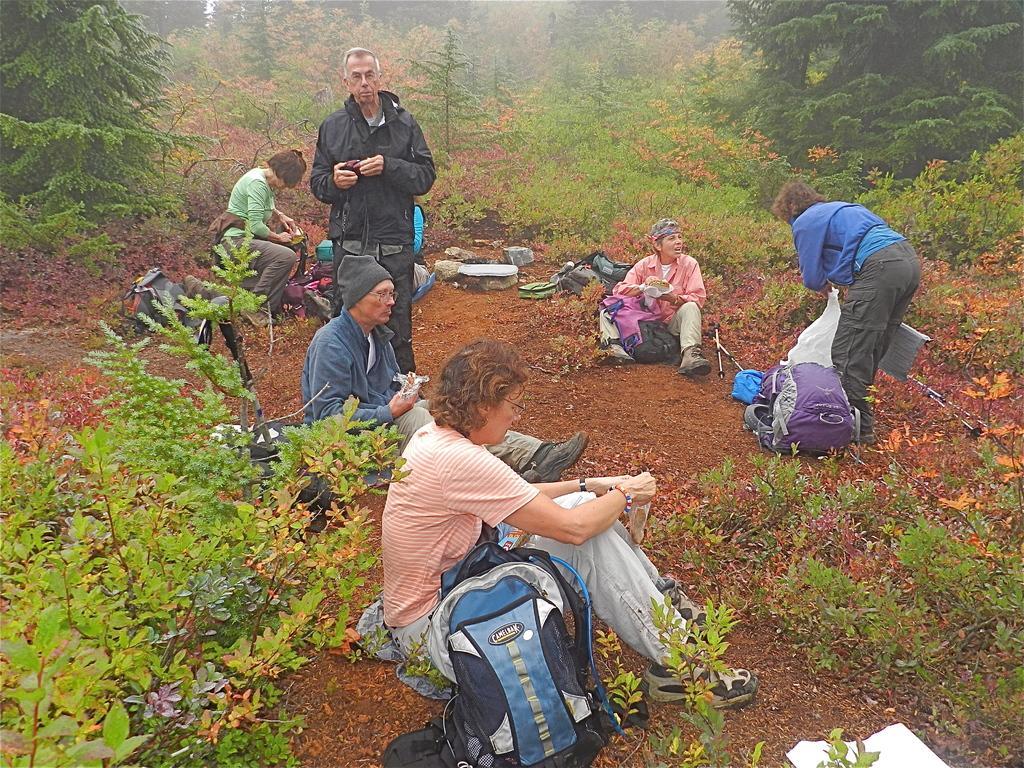Can you describe this image briefly? In this image we can see two men and four women. Few are sitting on the land and two persons are standing. Behind the trees are there. At the bottom of the image plants and we can see one bag. 